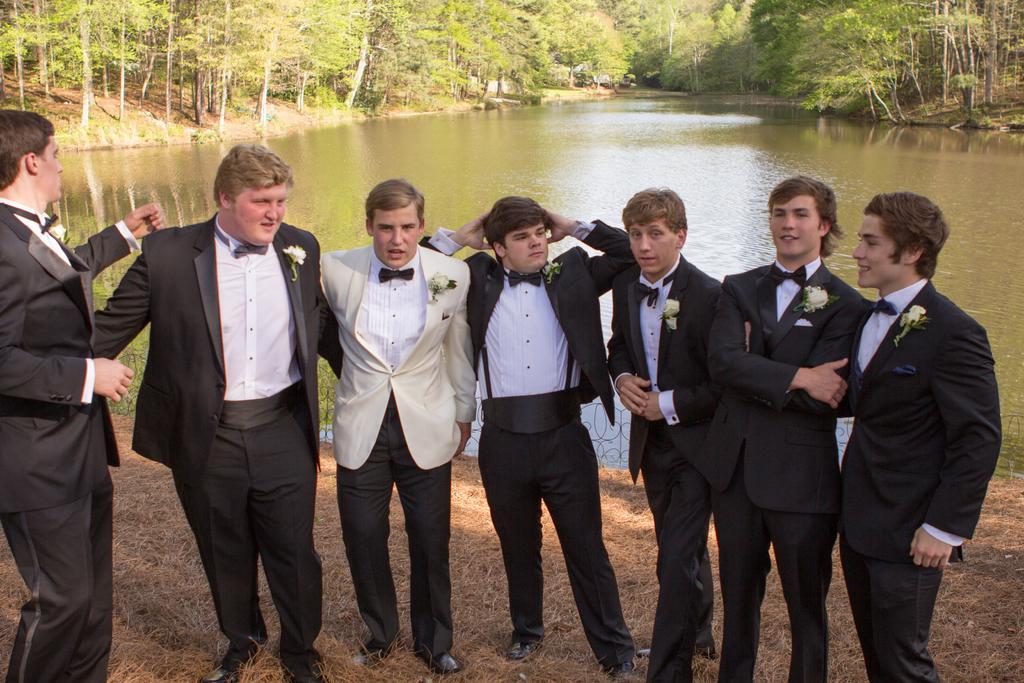Describe this image in one or two sentences. In this image we can see the people wearing the suits and standing. We can also see the trees, water and at the bottom we can see the dried grass. 